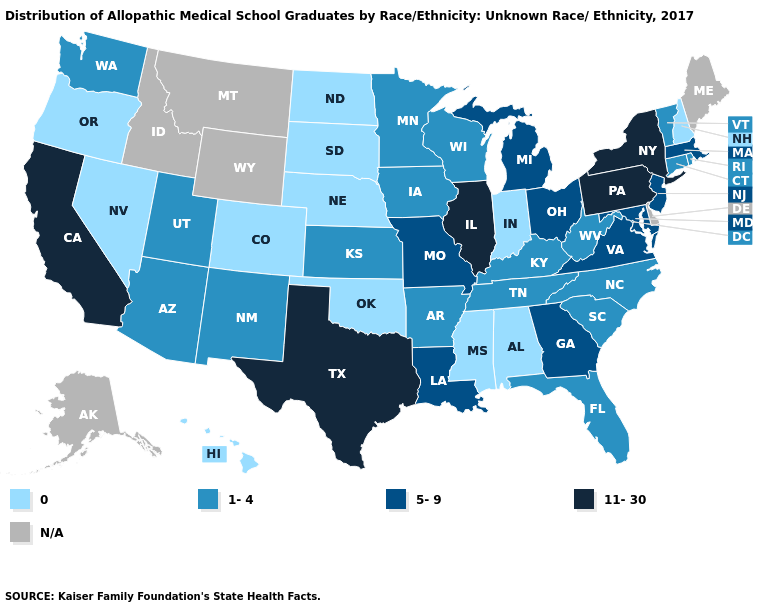Name the states that have a value in the range 1-4?
Give a very brief answer. Arizona, Arkansas, Connecticut, Florida, Iowa, Kansas, Kentucky, Minnesota, New Mexico, North Carolina, Rhode Island, South Carolina, Tennessee, Utah, Vermont, Washington, West Virginia, Wisconsin. Is the legend a continuous bar?
Concise answer only. No. What is the value of Rhode Island?
Write a very short answer. 1-4. What is the lowest value in the West?
Give a very brief answer. 0. Name the states that have a value in the range 5-9?
Concise answer only. Georgia, Louisiana, Maryland, Massachusetts, Michigan, Missouri, New Jersey, Ohio, Virginia. Name the states that have a value in the range 1-4?
Write a very short answer. Arizona, Arkansas, Connecticut, Florida, Iowa, Kansas, Kentucky, Minnesota, New Mexico, North Carolina, Rhode Island, South Carolina, Tennessee, Utah, Vermont, Washington, West Virginia, Wisconsin. What is the value of Tennessee?
Concise answer only. 1-4. Does the first symbol in the legend represent the smallest category?
Short answer required. Yes. Does Rhode Island have the lowest value in the Northeast?
Be succinct. No. Is the legend a continuous bar?
Give a very brief answer. No. Which states have the lowest value in the USA?
Be succinct. Alabama, Colorado, Hawaii, Indiana, Mississippi, Nebraska, Nevada, New Hampshire, North Dakota, Oklahoma, Oregon, South Dakota. Name the states that have a value in the range 5-9?
Concise answer only. Georgia, Louisiana, Maryland, Massachusetts, Michigan, Missouri, New Jersey, Ohio, Virginia. 